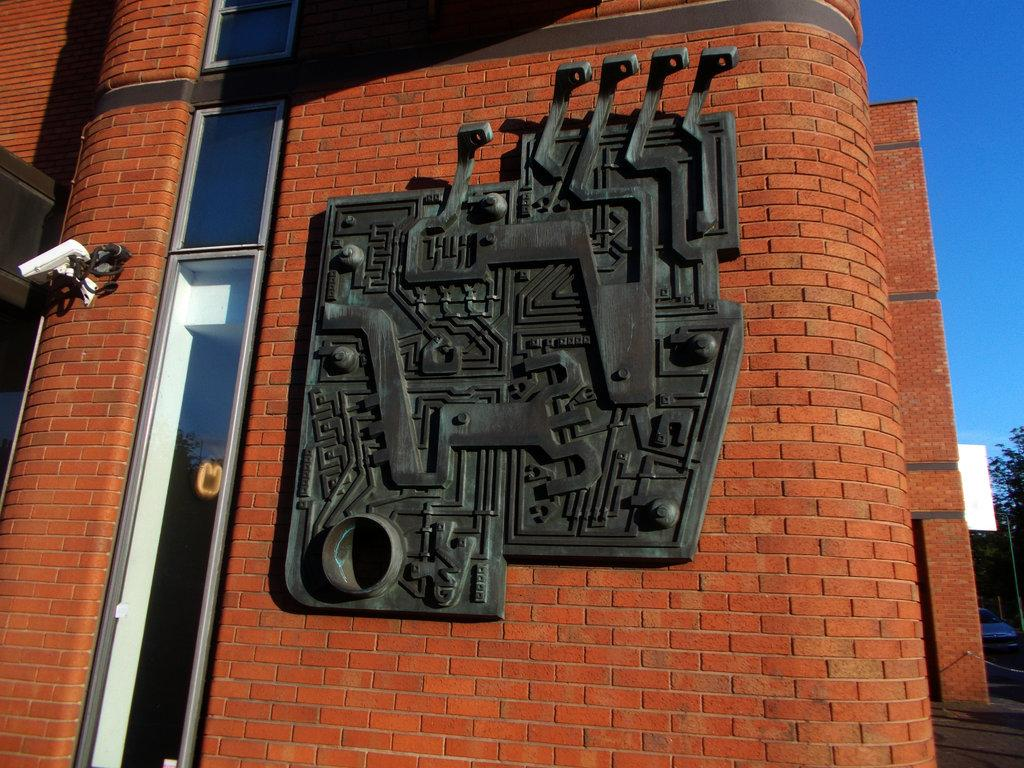What type of structure is visible in the image? There is a building in the image. What objects can be seen in the image besides the building? There are glasses and trees visible in the image. Can you describe any other objects in the image? Yes, there are other objects in the image, but their specific details are not mentioned in the provided facts. What part of the sky is visible in the image? The sky is visible on the right side of the image. What type of yarn is being used to create the building in the image? There is no yarn present in the image, and the building is not made of yarn. 